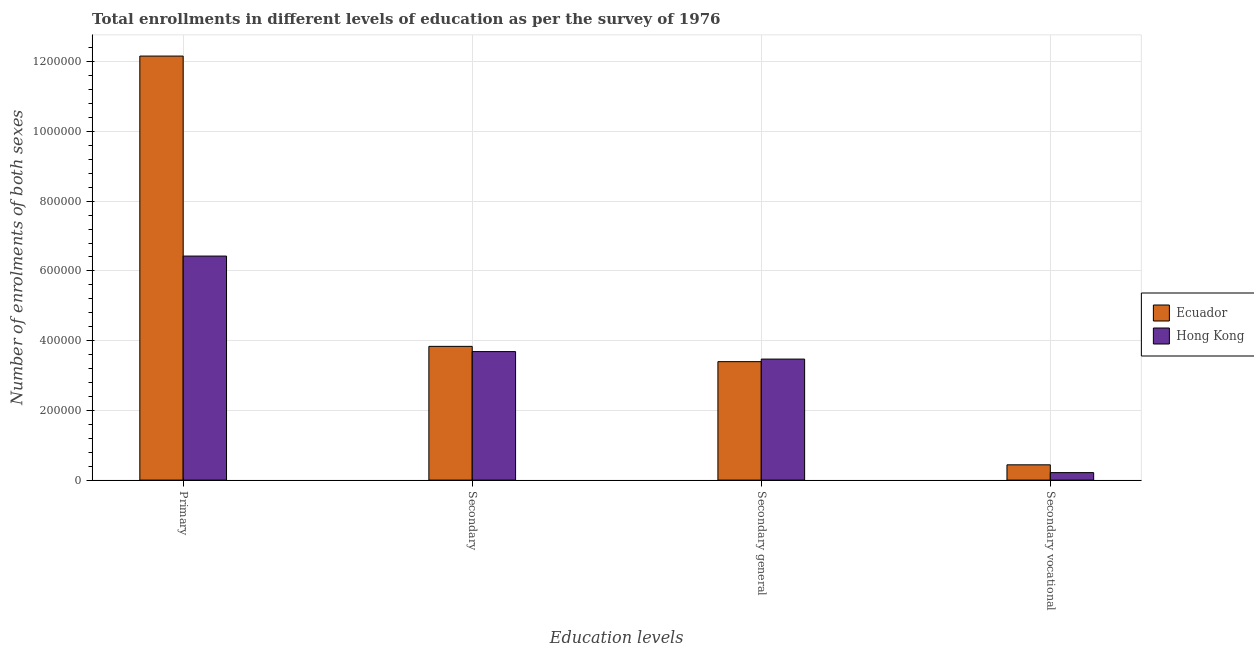What is the label of the 4th group of bars from the left?
Your answer should be compact. Secondary vocational. What is the number of enrolments in primary education in Hong Kong?
Make the answer very short. 6.43e+05. Across all countries, what is the maximum number of enrolments in secondary vocational education?
Your answer should be compact. 4.39e+04. Across all countries, what is the minimum number of enrolments in secondary general education?
Give a very brief answer. 3.40e+05. In which country was the number of enrolments in primary education maximum?
Provide a succinct answer. Ecuador. In which country was the number of enrolments in primary education minimum?
Provide a succinct answer. Hong Kong. What is the total number of enrolments in secondary education in the graph?
Your answer should be very brief. 7.52e+05. What is the difference between the number of enrolments in secondary education in Hong Kong and that in Ecuador?
Provide a short and direct response. -1.50e+04. What is the difference between the number of enrolments in secondary education in Ecuador and the number of enrolments in primary education in Hong Kong?
Provide a short and direct response. -2.59e+05. What is the average number of enrolments in secondary general education per country?
Your answer should be compact. 3.43e+05. What is the difference between the number of enrolments in secondary education and number of enrolments in secondary vocational education in Ecuador?
Offer a terse response. 3.40e+05. What is the ratio of the number of enrolments in secondary education in Hong Kong to that in Ecuador?
Your response must be concise. 0.96. What is the difference between the highest and the second highest number of enrolments in secondary vocational education?
Offer a very short reply. 2.23e+04. What is the difference between the highest and the lowest number of enrolments in secondary general education?
Give a very brief answer. 7375. In how many countries, is the number of enrolments in secondary vocational education greater than the average number of enrolments in secondary vocational education taken over all countries?
Keep it short and to the point. 1. Is the sum of the number of enrolments in secondary education in Hong Kong and Ecuador greater than the maximum number of enrolments in secondary vocational education across all countries?
Provide a succinct answer. Yes. Is it the case that in every country, the sum of the number of enrolments in secondary education and number of enrolments in secondary vocational education is greater than the sum of number of enrolments in primary education and number of enrolments in secondary general education?
Give a very brief answer. No. What does the 2nd bar from the left in Secondary vocational represents?
Your answer should be compact. Hong Kong. What does the 1st bar from the right in Secondary vocational represents?
Give a very brief answer. Hong Kong. Is it the case that in every country, the sum of the number of enrolments in primary education and number of enrolments in secondary education is greater than the number of enrolments in secondary general education?
Your response must be concise. Yes. Are all the bars in the graph horizontal?
Offer a terse response. No. How many countries are there in the graph?
Ensure brevity in your answer.  2. Are the values on the major ticks of Y-axis written in scientific E-notation?
Make the answer very short. No. Does the graph contain any zero values?
Keep it short and to the point. No. Where does the legend appear in the graph?
Offer a very short reply. Center right. How many legend labels are there?
Provide a short and direct response. 2. How are the legend labels stacked?
Your answer should be compact. Vertical. What is the title of the graph?
Your answer should be compact. Total enrollments in different levels of education as per the survey of 1976. What is the label or title of the X-axis?
Keep it short and to the point. Education levels. What is the label or title of the Y-axis?
Offer a very short reply. Number of enrolments of both sexes. What is the Number of enrolments of both sexes of Ecuador in Primary?
Your response must be concise. 1.22e+06. What is the Number of enrolments of both sexes of Hong Kong in Primary?
Your answer should be very brief. 6.43e+05. What is the Number of enrolments of both sexes in Ecuador in Secondary?
Make the answer very short. 3.84e+05. What is the Number of enrolments of both sexes of Hong Kong in Secondary?
Your response must be concise. 3.69e+05. What is the Number of enrolments of both sexes in Ecuador in Secondary general?
Ensure brevity in your answer.  3.40e+05. What is the Number of enrolments of both sexes in Hong Kong in Secondary general?
Your answer should be very brief. 3.47e+05. What is the Number of enrolments of both sexes in Ecuador in Secondary vocational?
Offer a terse response. 4.39e+04. What is the Number of enrolments of both sexes in Hong Kong in Secondary vocational?
Provide a succinct answer. 2.15e+04. Across all Education levels, what is the maximum Number of enrolments of both sexes in Ecuador?
Keep it short and to the point. 1.22e+06. Across all Education levels, what is the maximum Number of enrolments of both sexes in Hong Kong?
Give a very brief answer. 6.43e+05. Across all Education levels, what is the minimum Number of enrolments of both sexes of Ecuador?
Keep it short and to the point. 4.39e+04. Across all Education levels, what is the minimum Number of enrolments of both sexes of Hong Kong?
Keep it short and to the point. 2.15e+04. What is the total Number of enrolments of both sexes of Ecuador in the graph?
Give a very brief answer. 1.98e+06. What is the total Number of enrolments of both sexes in Hong Kong in the graph?
Offer a very short reply. 1.38e+06. What is the difference between the Number of enrolments of both sexes in Ecuador in Primary and that in Secondary?
Provide a succinct answer. 8.33e+05. What is the difference between the Number of enrolments of both sexes of Hong Kong in Primary and that in Secondary?
Your answer should be compact. 2.74e+05. What is the difference between the Number of enrolments of both sexes in Ecuador in Primary and that in Secondary general?
Ensure brevity in your answer.  8.76e+05. What is the difference between the Number of enrolments of both sexes of Hong Kong in Primary and that in Secondary general?
Make the answer very short. 2.95e+05. What is the difference between the Number of enrolments of both sexes in Ecuador in Primary and that in Secondary vocational?
Provide a short and direct response. 1.17e+06. What is the difference between the Number of enrolments of both sexes of Hong Kong in Primary and that in Secondary vocational?
Ensure brevity in your answer.  6.21e+05. What is the difference between the Number of enrolments of both sexes in Ecuador in Secondary and that in Secondary general?
Offer a very short reply. 4.39e+04. What is the difference between the Number of enrolments of both sexes of Hong Kong in Secondary and that in Secondary general?
Provide a short and direct response. 2.15e+04. What is the difference between the Number of enrolments of both sexes of Ecuador in Secondary and that in Secondary vocational?
Your response must be concise. 3.40e+05. What is the difference between the Number of enrolments of both sexes in Hong Kong in Secondary and that in Secondary vocational?
Ensure brevity in your answer.  3.47e+05. What is the difference between the Number of enrolments of both sexes in Ecuador in Secondary general and that in Secondary vocational?
Ensure brevity in your answer.  2.96e+05. What is the difference between the Number of enrolments of both sexes of Hong Kong in Secondary general and that in Secondary vocational?
Your answer should be compact. 3.26e+05. What is the difference between the Number of enrolments of both sexes in Ecuador in Primary and the Number of enrolments of both sexes in Hong Kong in Secondary?
Make the answer very short. 8.48e+05. What is the difference between the Number of enrolments of both sexes of Ecuador in Primary and the Number of enrolments of both sexes of Hong Kong in Secondary general?
Make the answer very short. 8.69e+05. What is the difference between the Number of enrolments of both sexes of Ecuador in Primary and the Number of enrolments of both sexes of Hong Kong in Secondary vocational?
Provide a short and direct response. 1.19e+06. What is the difference between the Number of enrolments of both sexes in Ecuador in Secondary and the Number of enrolments of both sexes in Hong Kong in Secondary general?
Keep it short and to the point. 3.65e+04. What is the difference between the Number of enrolments of both sexes in Ecuador in Secondary and the Number of enrolments of both sexes in Hong Kong in Secondary vocational?
Your response must be concise. 3.62e+05. What is the difference between the Number of enrolments of both sexes in Ecuador in Secondary general and the Number of enrolments of both sexes in Hong Kong in Secondary vocational?
Your answer should be very brief. 3.18e+05. What is the average Number of enrolments of both sexes of Ecuador per Education levels?
Offer a terse response. 4.96e+05. What is the average Number of enrolments of both sexes of Hong Kong per Education levels?
Give a very brief answer. 3.45e+05. What is the difference between the Number of enrolments of both sexes in Ecuador and Number of enrolments of both sexes in Hong Kong in Primary?
Your answer should be very brief. 5.74e+05. What is the difference between the Number of enrolments of both sexes in Ecuador and Number of enrolments of both sexes in Hong Kong in Secondary?
Give a very brief answer. 1.50e+04. What is the difference between the Number of enrolments of both sexes in Ecuador and Number of enrolments of both sexes in Hong Kong in Secondary general?
Ensure brevity in your answer.  -7375. What is the difference between the Number of enrolments of both sexes of Ecuador and Number of enrolments of both sexes of Hong Kong in Secondary vocational?
Keep it short and to the point. 2.23e+04. What is the ratio of the Number of enrolments of both sexes in Ecuador in Primary to that in Secondary?
Provide a succinct answer. 3.17. What is the ratio of the Number of enrolments of both sexes of Hong Kong in Primary to that in Secondary?
Offer a terse response. 1.74. What is the ratio of the Number of enrolments of both sexes of Ecuador in Primary to that in Secondary general?
Provide a short and direct response. 3.58. What is the ratio of the Number of enrolments of both sexes of Hong Kong in Primary to that in Secondary general?
Offer a terse response. 1.85. What is the ratio of the Number of enrolments of both sexes in Ecuador in Primary to that in Secondary vocational?
Offer a terse response. 27.73. What is the ratio of the Number of enrolments of both sexes of Hong Kong in Primary to that in Secondary vocational?
Your answer should be very brief. 29.88. What is the ratio of the Number of enrolments of both sexes in Ecuador in Secondary to that in Secondary general?
Offer a very short reply. 1.13. What is the ratio of the Number of enrolments of both sexes of Hong Kong in Secondary to that in Secondary general?
Make the answer very short. 1.06. What is the ratio of the Number of enrolments of both sexes of Ecuador in Secondary to that in Secondary vocational?
Your response must be concise. 8.75. What is the ratio of the Number of enrolments of both sexes in Hong Kong in Secondary to that in Secondary vocational?
Provide a short and direct response. 17.14. What is the ratio of the Number of enrolments of both sexes of Ecuador in Secondary general to that in Secondary vocational?
Provide a succinct answer. 7.75. What is the ratio of the Number of enrolments of both sexes in Hong Kong in Secondary general to that in Secondary vocational?
Make the answer very short. 16.14. What is the difference between the highest and the second highest Number of enrolments of both sexes in Ecuador?
Make the answer very short. 8.33e+05. What is the difference between the highest and the second highest Number of enrolments of both sexes of Hong Kong?
Offer a very short reply. 2.74e+05. What is the difference between the highest and the lowest Number of enrolments of both sexes of Ecuador?
Your answer should be compact. 1.17e+06. What is the difference between the highest and the lowest Number of enrolments of both sexes in Hong Kong?
Your response must be concise. 6.21e+05. 